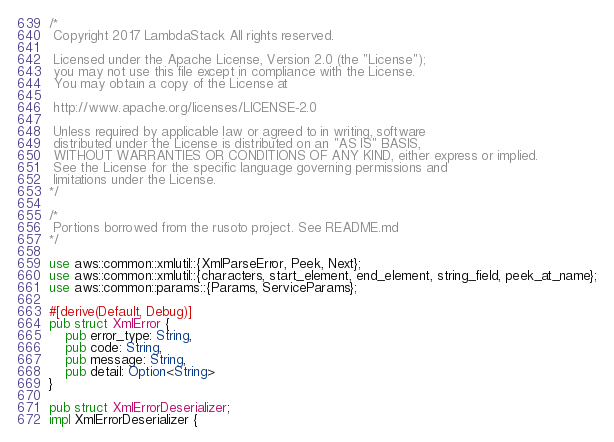<code> <loc_0><loc_0><loc_500><loc_500><_Rust_>/*
 Copyright 2017 LambdaStack All rights reserved.

 Licensed under the Apache License, Version 2.0 (the "License");
 you may not use this file except in compliance with the License.
 You may obtain a copy of the License at

 http://www.apache.org/licenses/LICENSE-2.0

 Unless required by applicable law or agreed to in writing, software
 distributed under the License is distributed on an "AS IS" BASIS,
 WITHOUT WARRANTIES OR CONDITIONS OF ANY KIND, either express or implied.
 See the License for the specific language governing permissions and
 limitations under the License.
*/

/*
 Portions borrowed from the rusoto project. See README.md
*/

use aws::common::xmlutil::{XmlParseError, Peek, Next};
use aws::common::xmlutil::{characters, start_element, end_element, string_field, peek_at_name};
use aws::common::params::{Params, ServiceParams};

#[derive(Default, Debug)]
pub struct XmlError {
	pub error_type: String,
	pub code: String,
	pub message: String,
	pub detail: Option<String>
}

pub struct XmlErrorDeserializer;
impl XmlErrorDeserializer {</code> 